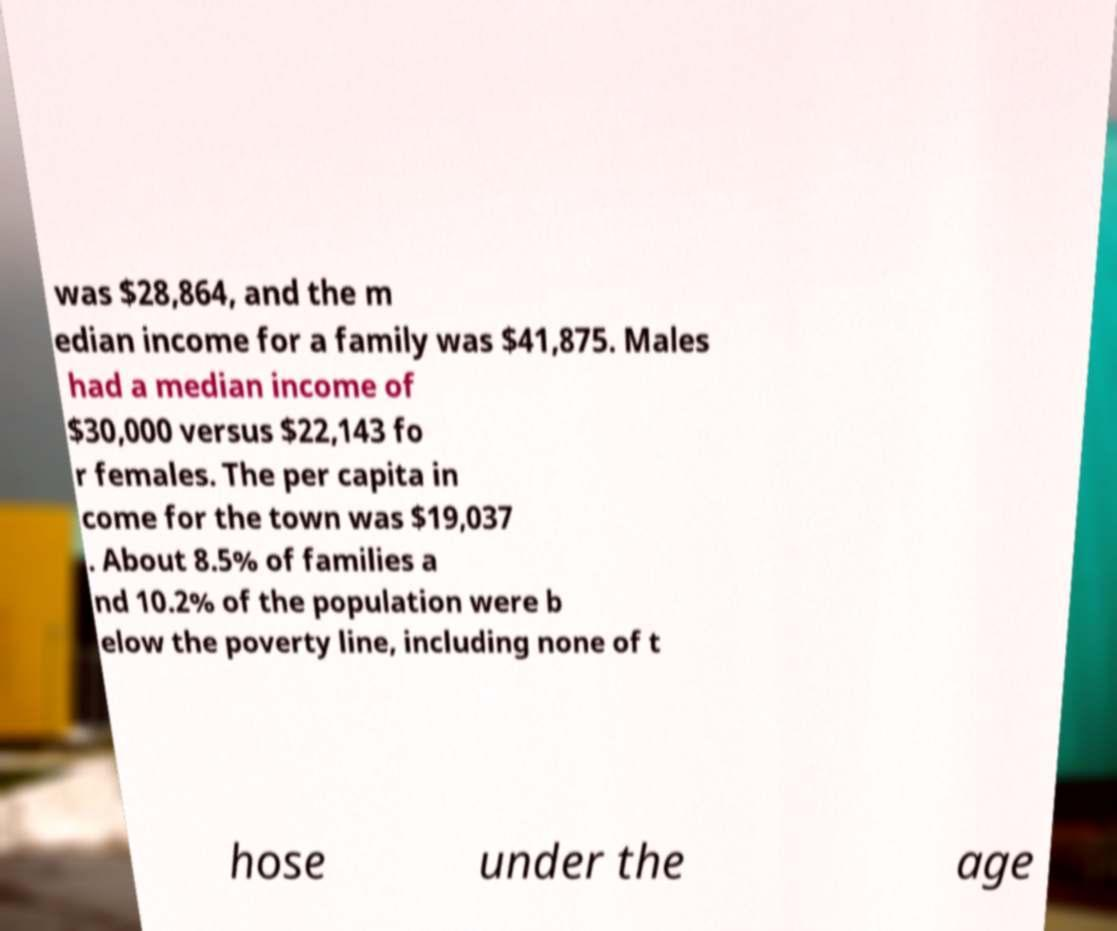Please identify and transcribe the text found in this image. was $28,864, and the m edian income for a family was $41,875. Males had a median income of $30,000 versus $22,143 fo r females. The per capita in come for the town was $19,037 . About 8.5% of families a nd 10.2% of the population were b elow the poverty line, including none of t hose under the age 